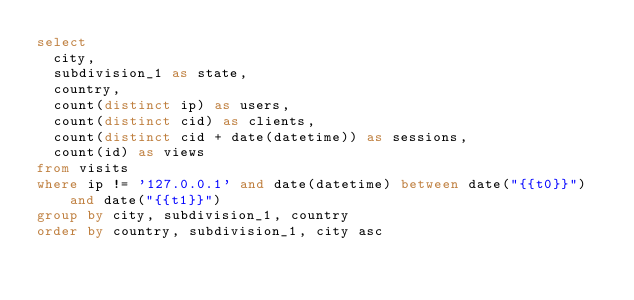Convert code to text. <code><loc_0><loc_0><loc_500><loc_500><_SQL_>select
  city,
  subdivision_1 as state,
  country,
  count(distinct ip) as users,
  count(distinct cid) as clients,
  count(distinct cid + date(datetime)) as sessions,
  count(id) as views
from visits
where ip != '127.0.0.1' and date(datetime) between date("{{t0}}") and date("{{t1}}")
group by city, subdivision_1, country
order by country, subdivision_1, city asc
</code> 